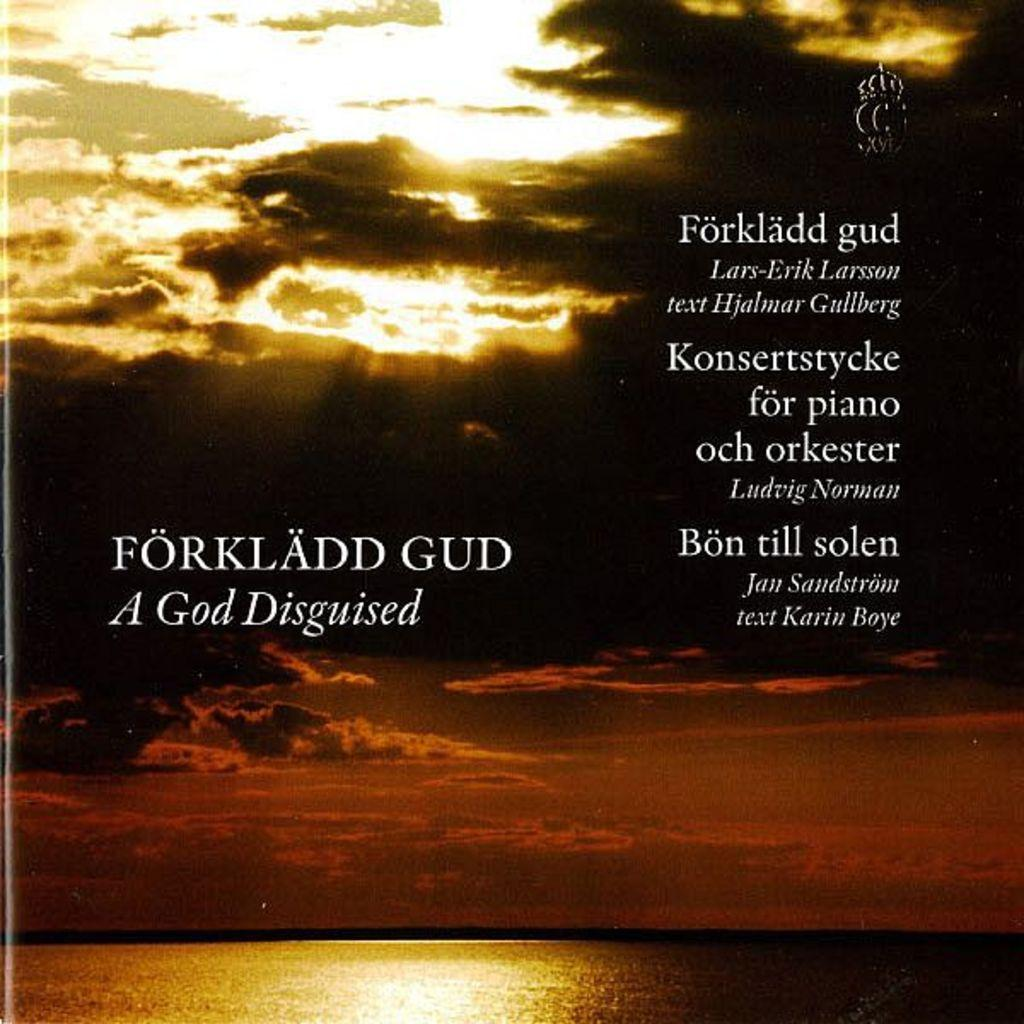<image>
Share a concise interpretation of the image provided. the word forkladd gud is next to some other names 